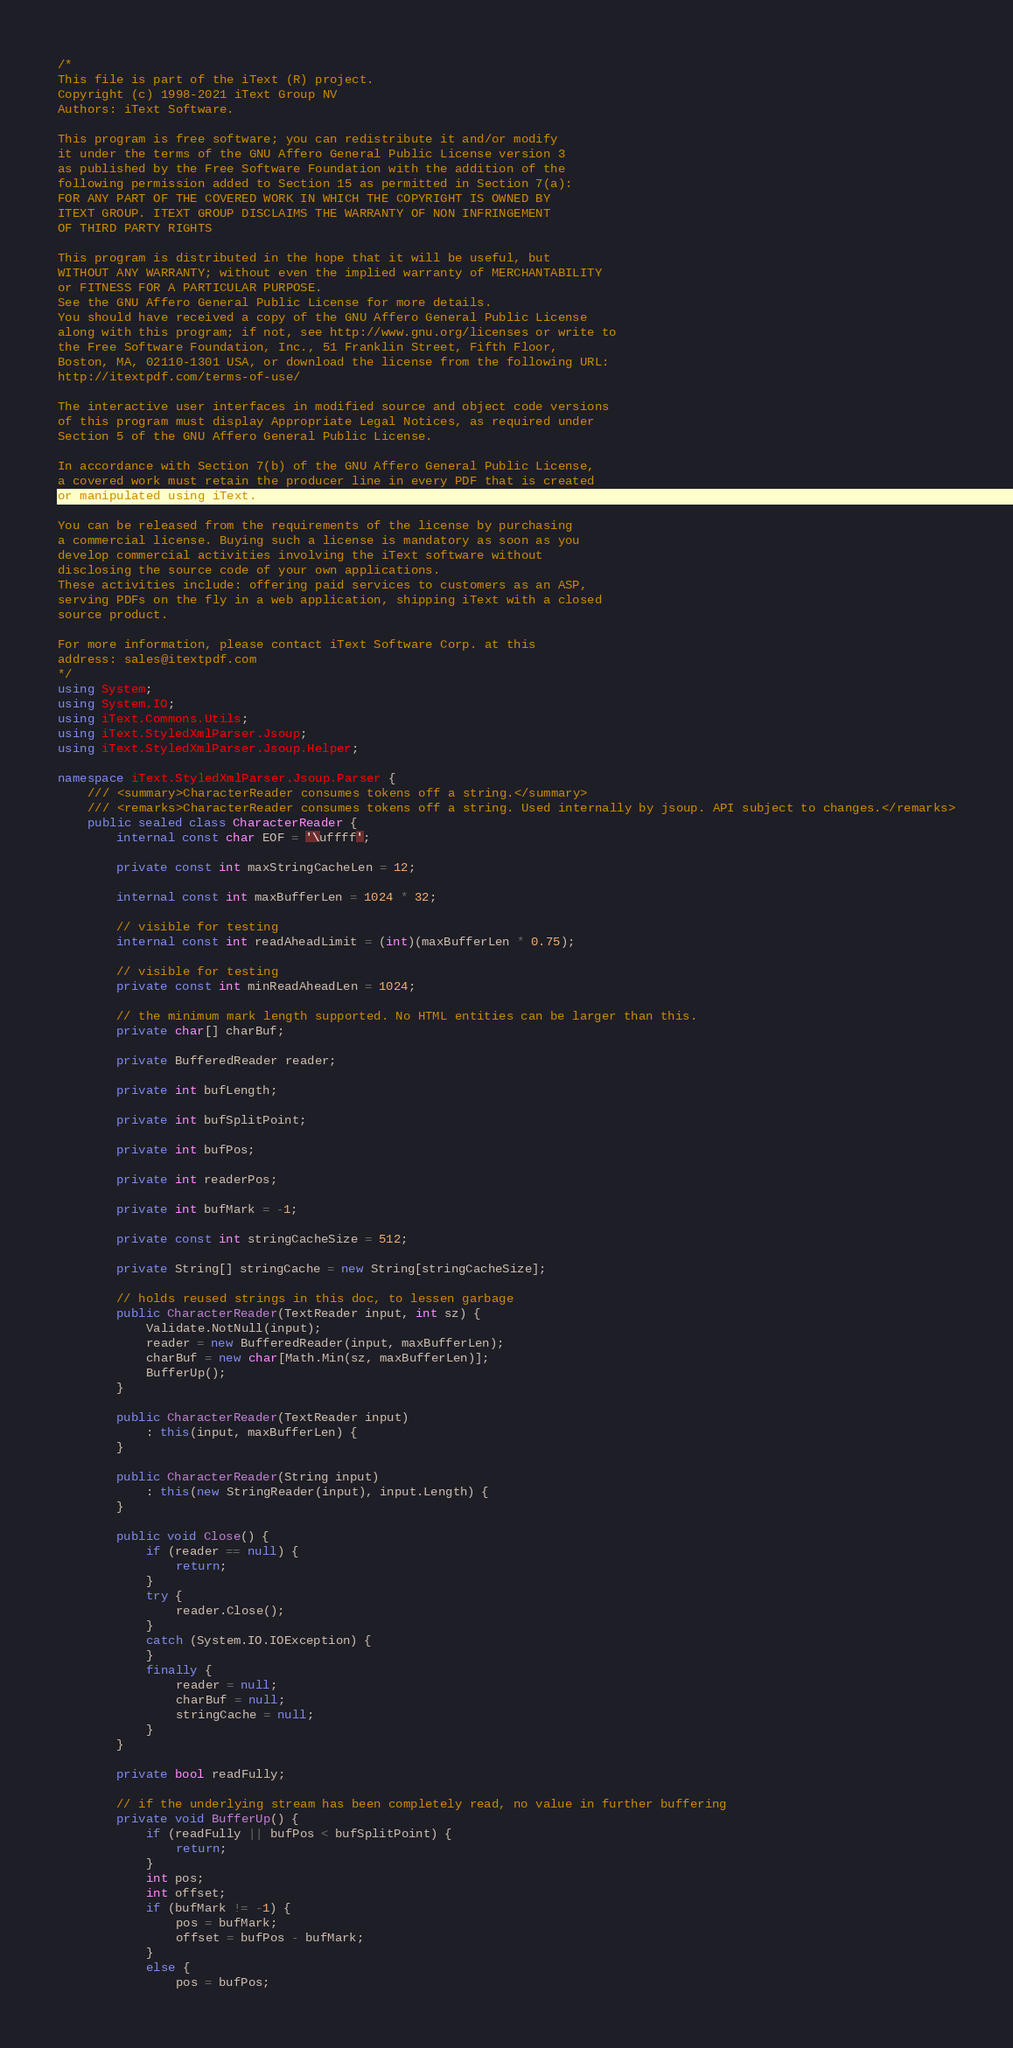<code> <loc_0><loc_0><loc_500><loc_500><_C#_>/*
This file is part of the iText (R) project.
Copyright (c) 1998-2021 iText Group NV
Authors: iText Software.

This program is free software; you can redistribute it and/or modify
it under the terms of the GNU Affero General Public License version 3
as published by the Free Software Foundation with the addition of the
following permission added to Section 15 as permitted in Section 7(a):
FOR ANY PART OF THE COVERED WORK IN WHICH THE COPYRIGHT IS OWNED BY
ITEXT GROUP. ITEXT GROUP DISCLAIMS THE WARRANTY OF NON INFRINGEMENT
OF THIRD PARTY RIGHTS

This program is distributed in the hope that it will be useful, but
WITHOUT ANY WARRANTY; without even the implied warranty of MERCHANTABILITY
or FITNESS FOR A PARTICULAR PURPOSE.
See the GNU Affero General Public License for more details.
You should have received a copy of the GNU Affero General Public License
along with this program; if not, see http://www.gnu.org/licenses or write to
the Free Software Foundation, Inc., 51 Franklin Street, Fifth Floor,
Boston, MA, 02110-1301 USA, or download the license from the following URL:
http://itextpdf.com/terms-of-use/

The interactive user interfaces in modified source and object code versions
of this program must display Appropriate Legal Notices, as required under
Section 5 of the GNU Affero General Public License.

In accordance with Section 7(b) of the GNU Affero General Public License,
a covered work must retain the producer line in every PDF that is created
or manipulated using iText.

You can be released from the requirements of the license by purchasing
a commercial license. Buying such a license is mandatory as soon as you
develop commercial activities involving the iText software without
disclosing the source code of your own applications.
These activities include: offering paid services to customers as an ASP,
serving PDFs on the fly in a web application, shipping iText with a closed
source product.

For more information, please contact iText Software Corp. at this
address: sales@itextpdf.com
*/
using System;
using System.IO;
using iText.Commons.Utils;
using iText.StyledXmlParser.Jsoup;
using iText.StyledXmlParser.Jsoup.Helper;

namespace iText.StyledXmlParser.Jsoup.Parser {
    /// <summary>CharacterReader consumes tokens off a string.</summary>
    /// <remarks>CharacterReader consumes tokens off a string. Used internally by jsoup. API subject to changes.</remarks>
    public sealed class CharacterReader {
        internal const char EOF = '\uffff';

        private const int maxStringCacheLen = 12;

        internal const int maxBufferLen = 1024 * 32;

        // visible for testing
        internal const int readAheadLimit = (int)(maxBufferLen * 0.75);

        // visible for testing
        private const int minReadAheadLen = 1024;

        // the minimum mark length supported. No HTML entities can be larger than this.
        private char[] charBuf;

        private BufferedReader reader;

        private int bufLength;

        private int bufSplitPoint;

        private int bufPos;

        private int readerPos;

        private int bufMark = -1;

        private const int stringCacheSize = 512;

        private String[] stringCache = new String[stringCacheSize];

        // holds reused strings in this doc, to lessen garbage
        public CharacterReader(TextReader input, int sz) {
            Validate.NotNull(input);
            reader = new BufferedReader(input, maxBufferLen);
            charBuf = new char[Math.Min(sz, maxBufferLen)];
            BufferUp();
        }

        public CharacterReader(TextReader input)
            : this(input, maxBufferLen) {
        }

        public CharacterReader(String input)
            : this(new StringReader(input), input.Length) {
        }

        public void Close() {
            if (reader == null) {
                return;
            }
            try {
                reader.Close();
            }
            catch (System.IO.IOException) {
            }
            finally {
                reader = null;
                charBuf = null;
                stringCache = null;
            }
        }

        private bool readFully;

        // if the underlying stream has been completely read, no value in further buffering
        private void BufferUp() {
            if (readFully || bufPos < bufSplitPoint) {
                return;
            }
            int pos;
            int offset;
            if (bufMark != -1) {
                pos = bufMark;
                offset = bufPos - bufMark;
            }
            else {
                pos = bufPos;</code> 